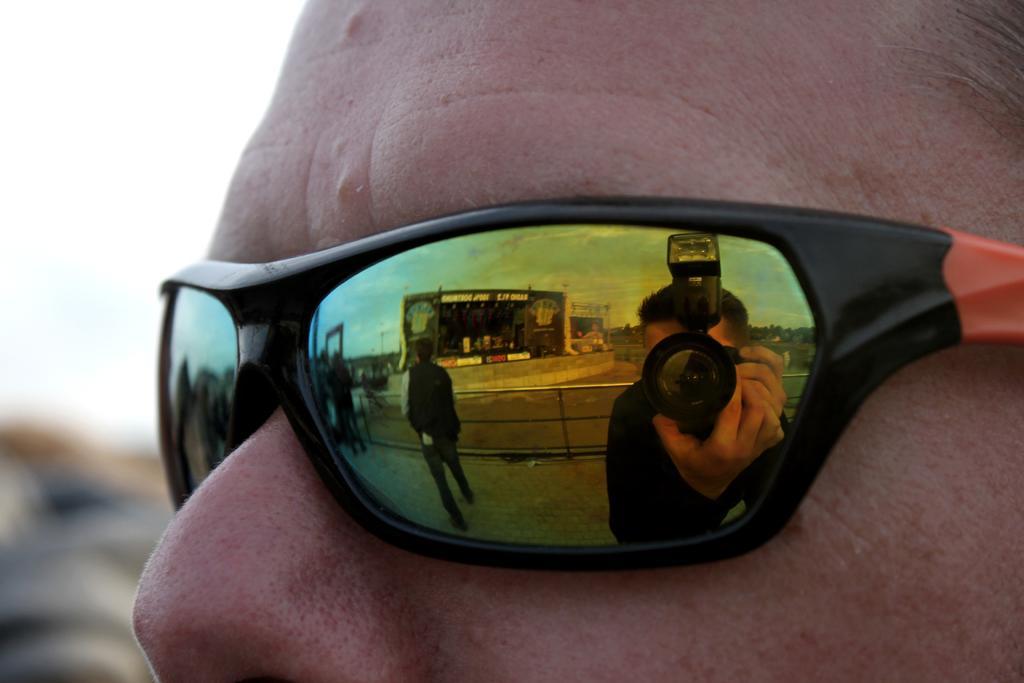Describe this image in one or two sentences. In the image we can see goggles to a person eyes. On the glasses of the goggles we can see the reflections of few person's, a person holding camera in the hands, trees, fence, buildings and clouds in the sky. In the background the image is blur. 